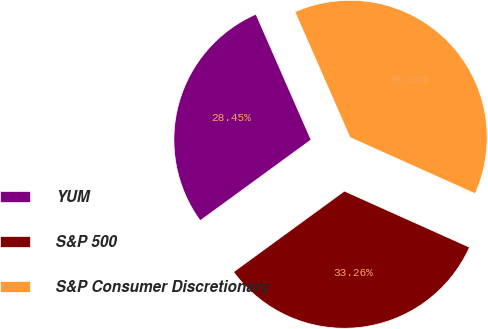Convert chart to OTSL. <chart><loc_0><loc_0><loc_500><loc_500><pie_chart><fcel>YUM<fcel>S&P 500<fcel>S&P Consumer Discretionary<nl><fcel>28.45%<fcel>33.26%<fcel>38.29%<nl></chart> 